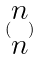<formula> <loc_0><loc_0><loc_500><loc_500>( \begin{matrix} n \\ n \end{matrix} )</formula> 